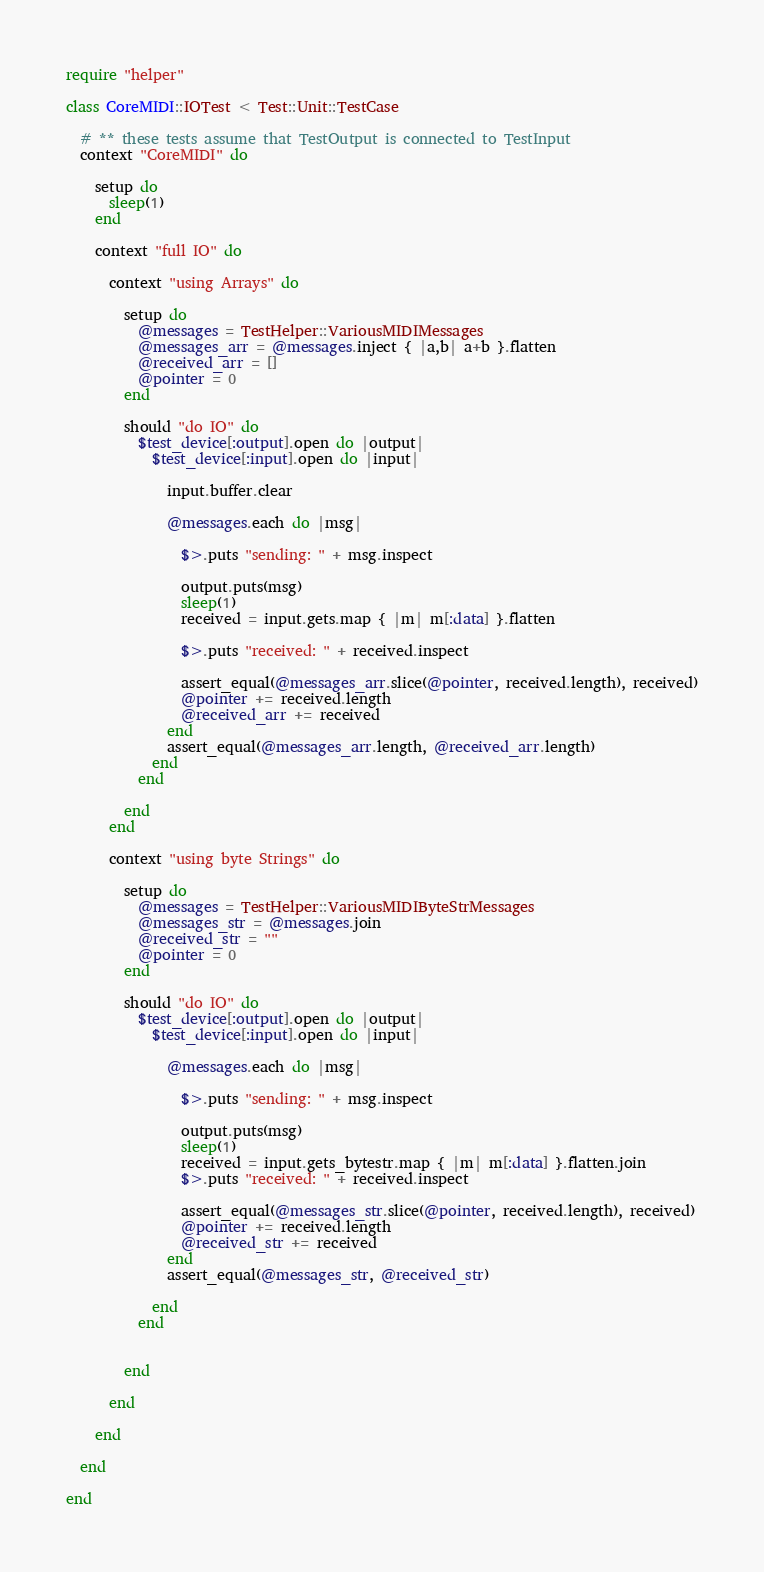Convert code to text. <code><loc_0><loc_0><loc_500><loc_500><_Ruby_>require "helper"

class CoreMIDI::IOTest < Test::Unit::TestCase

  # ** these tests assume that TestOutput is connected to TestInput
  context "CoreMIDI" do

    setup do
      sleep(1)
    end

    context "full IO" do

      context "using Arrays" do

        setup do
          @messages = TestHelper::VariousMIDIMessages
          @messages_arr = @messages.inject { |a,b| a+b }.flatten
          @received_arr = []
          @pointer = 0
        end

        should "do IO" do
          $test_device[:output].open do |output|
            $test_device[:input].open do |input|

              input.buffer.clear

              @messages.each do |msg|

                $>.puts "sending: " + msg.inspect

                output.puts(msg)
                sleep(1)
                received = input.gets.map { |m| m[:data] }.flatten

                $>.puts "received: " + received.inspect

                assert_equal(@messages_arr.slice(@pointer, received.length), received)
                @pointer += received.length
                @received_arr += received
              end
              assert_equal(@messages_arr.length, @received_arr.length)
            end
          end

        end
      end

      context "using byte Strings" do

        setup do
          @messages = TestHelper::VariousMIDIByteStrMessages
          @messages_str = @messages.join
          @received_str = ""
          @pointer = 0
        end

        should "do IO" do
          $test_device[:output].open do |output|
            $test_device[:input].open do |input|

              @messages.each do |msg|

                $>.puts "sending: " + msg.inspect

                output.puts(msg)
                sleep(1)
                received = input.gets_bytestr.map { |m| m[:data] }.flatten.join
                $>.puts "received: " + received.inspect

                assert_equal(@messages_str.slice(@pointer, received.length), received)
                @pointer += received.length
                @received_str += received
              end
              assert_equal(@messages_str, @received_str)

            end
          end


        end

      end

    end

  end

end
</code> 